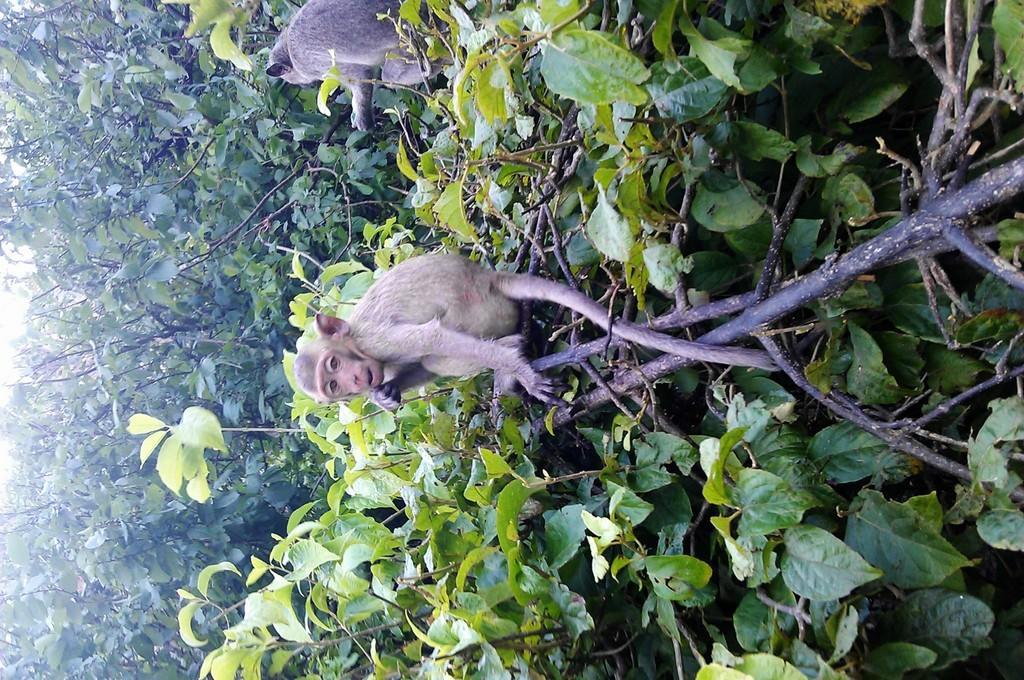Could you give a brief overview of what you see in this image? In this image, we can see two monkeys on the trees. Here we can see leaves, stems and branches. 